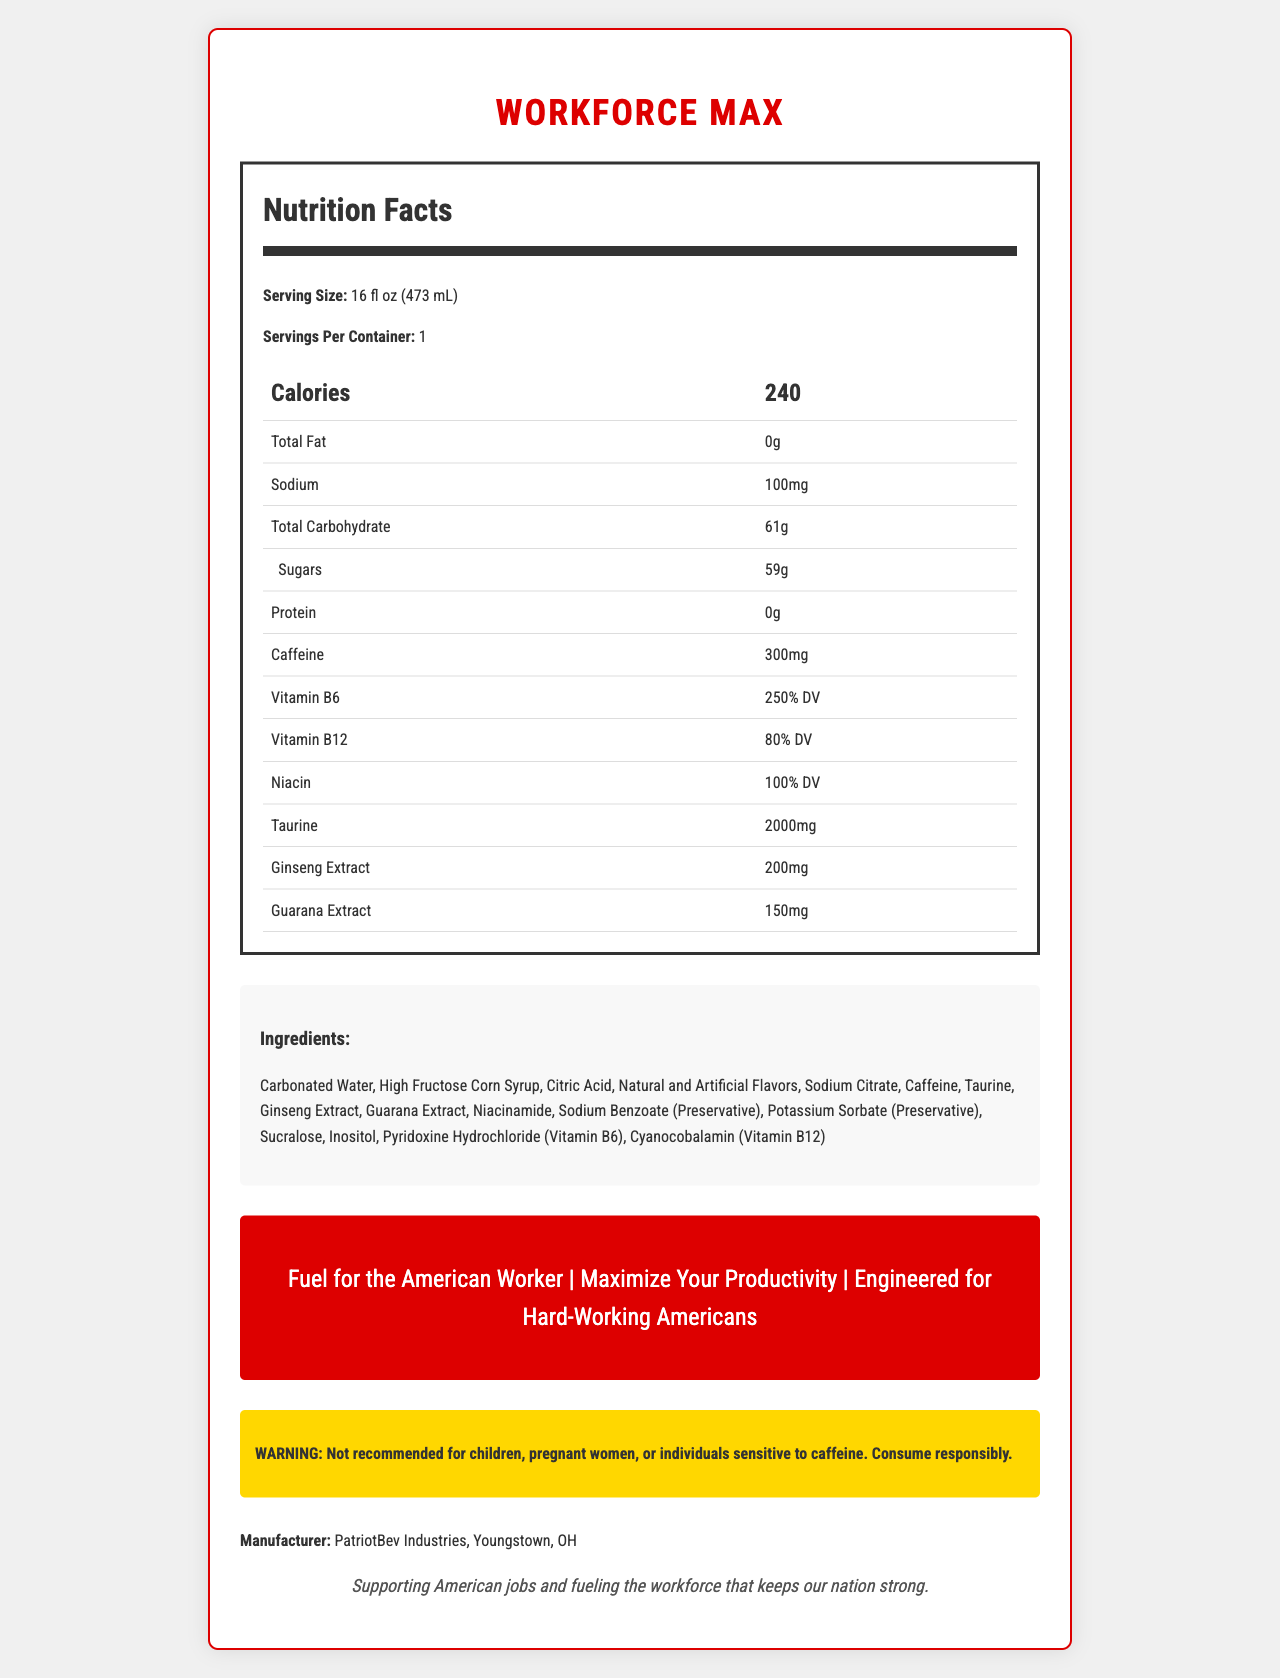What is the caffeine content per serving? The document states that the caffeine content is 300 mg per serving.
Answer: 300 mg How many calories does one serving contain? The Nutrition Facts section lists 240 calories per serving.
Answer: 240 calories What percentage of Vitamin B6 does WorkForce MAX provide? The document lists Vitamin B6 as providing 250% of the Daily Value.
Answer: 250% DV What is the first ingredient listed for WorkForce MAX? The Ingredients section of the document lists Carbonated Water as the first ingredient.
Answer: Carbonated Water Who is the manufacturer of WorkForce MAX? The manufacturer is listed at the bottom of the document.
Answer: PatriotBev Industries, Youngstown, OH How many grams of sugars are in one serving of WorkForce MAX? The Nutrition Facts indicates 59 grams of sugars per serving.
Answer: 59 grams What is the main cautionary statement provided? The document contains a warning in a distinct yellow box stating this caution.
Answer: "Not recommended for children, pregnant women, or individuals sensitive to caffeine. Consume responsibly." What are the three main marketing claims made about WorkForce MAX? These marketing claims are listed in a red-highlighted section for emphasis.
Answer: "Fuel for the American Worker," "Maximize Your Productivity," "Engineered for Hard-Working Americans" Which of the following ingredients is NOT listed in WorkForce MAX? A. Ginseng Extract B. Guarana Extract C. Aspartame Aspartame is not listed among the ingredients in the document.
Answer: C. Aspartame What is the main idea of the document? The document presents an energy drink designed for working Americans, highlighting its high caffeine and vitamin content, as well as cautionary statements and marketing claims.
Answer: WorkForce MAX is an energy drink promoted for blue-collar workers with high caffeine content and significant vitamins to boost productivity Based on the document, can we determine the effective duration of the energy drink's effects? The document does not provide any details on how long the energy drink's effects last.
Answer: Not enough information How much taurine is in one serving? The Nutrition Facts section lists 2000 mg of taurine per serving.
Answer: 2000 mg What percentage of the daily value for Vitamin B12 is provided by one serving? The document lists Vitamin B12 as providing 80% of the Daily Value.
Answer: 80% DV What is the serving size of WorkForce MAX? A. 12 fl oz B. 16 fl oz C. 20 fl oz D. 24 fl oz The serving size is clearly listed as 16 fl oz (473 mL).
Answer: B. 16 fl oz Is WorkForce MAX recommended for children? The cautionary statement explicitly says it is not recommended for children.
Answer: No What is the total carbohydrate content per serving? The Nutrition Facts section lists total carbohydrates as 61 grams per serving.
Answer: 61 grams 